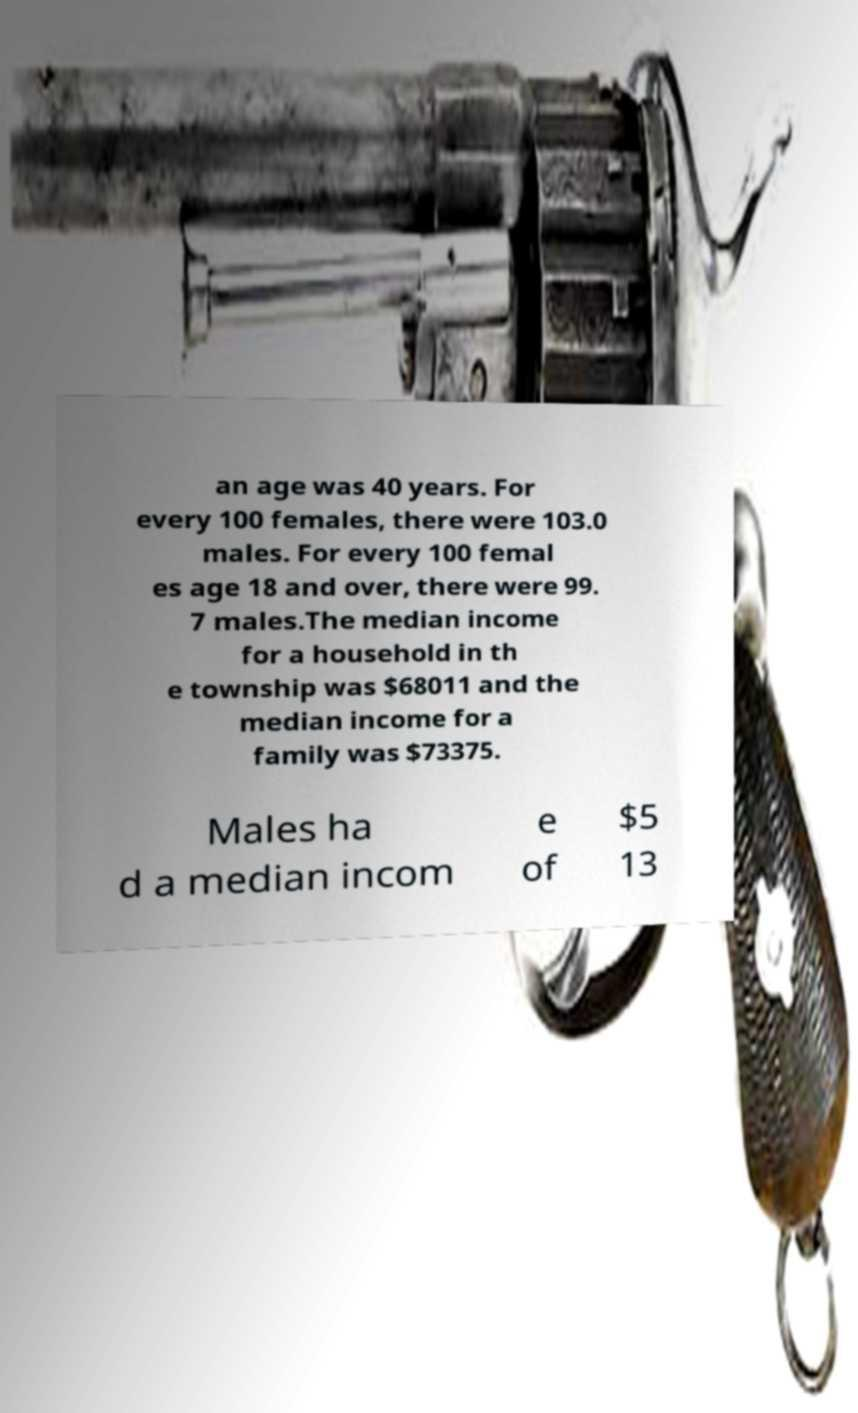There's text embedded in this image that I need extracted. Can you transcribe it verbatim? an age was 40 years. For every 100 females, there were 103.0 males. For every 100 femal es age 18 and over, there were 99. 7 males.The median income for a household in th e township was $68011 and the median income for a family was $73375. Males ha d a median incom e of $5 13 